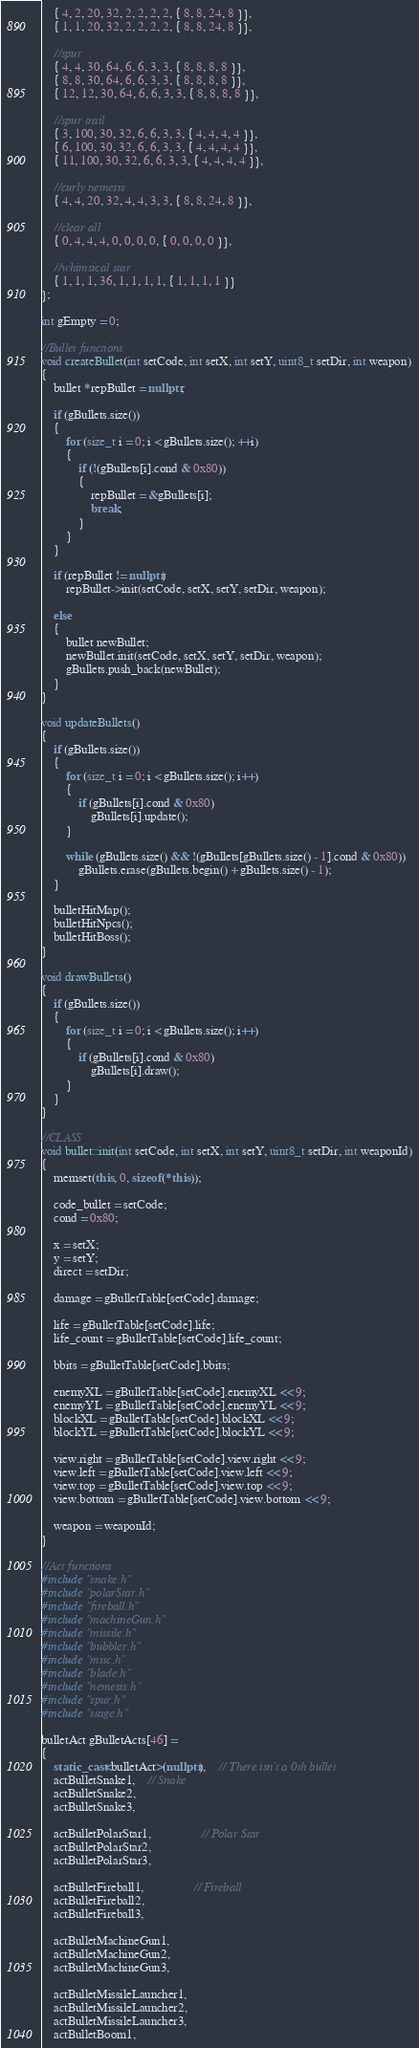Convert code to text. <code><loc_0><loc_0><loc_500><loc_500><_C++_>	{ 4, 2, 20, 32, 2, 2, 2, 2, { 8, 8, 24, 8 }},
	{ 1, 1, 20, 32, 2, 2, 2, 2, { 8, 8, 24, 8 }},

	//spur
	{ 4, 4, 30, 64, 6, 6, 3, 3, { 8, 8, 8, 8 }},
	{ 8, 8, 30, 64, 6, 6, 3, 3, { 8, 8, 8, 8 }},
	{ 12, 12, 30, 64, 6, 6, 3, 3, { 8, 8, 8, 8 }},

	//spur trail
	{ 3, 100, 30, 32, 6, 6, 3, 3, { 4, 4, 4, 4 }},
	{ 6, 100, 30, 32, 6, 6, 3, 3, { 4, 4, 4, 4 }},
	{ 11, 100, 30, 32, 6, 6, 3, 3, { 4, 4, 4, 4 }},

	//curly nemesis
	{ 4, 4, 20, 32, 4, 4, 3, 3, { 8, 8, 24, 8 }},

	//clear all
	{ 0, 4, 4, 4, 0, 0, 0, 0, { 0, 0, 0, 0 }},

	//whimsical star
	{ 1, 1, 1, 36, 1, 1, 1, 1, { 1, 1, 1, 1 }}
};

int gEmpty = 0;

//Bullet functions
void createBullet(int setCode, int setX, int setY, uint8_t setDir, int weapon)
{
	bullet *repBullet = nullptr;

	if (gBullets.size())
	{
		for (size_t i = 0; i < gBullets.size(); ++i)
		{
			if (!(gBullets[i].cond & 0x80))
			{
				repBullet = &gBullets[i];
				break;
			}
		}
	}

	if (repBullet != nullptr)
		repBullet->init(setCode, setX, setY, setDir, weapon);

	else
	{
		bullet newBullet;
		newBullet.init(setCode, setX, setY, setDir, weapon);
		gBullets.push_back(newBullet);
	}
}

void updateBullets()
{
	if (gBullets.size())
	{
		for (size_t i = 0; i < gBullets.size(); i++)
		{
			if (gBullets[i].cond & 0x80)
				gBullets[i].update();
		}

		while (gBullets.size() && !(gBullets[gBullets.size() - 1].cond & 0x80))
			gBullets.erase(gBullets.begin() + gBullets.size() - 1);
	}

	bulletHitMap();
	bulletHitNpcs();
	bulletHitBoss();
}

void drawBullets()
{
	if (gBullets.size())
	{
		for (size_t i = 0; i < gBullets.size(); i++)
		{
			if (gBullets[i].cond & 0x80)
				gBullets[i].draw();
		}
	}
}

//CLASS
void bullet::init(int setCode, int setX, int setY, uint8_t setDir, int weaponId)
{
	memset(this, 0, sizeof(*this));

	code_bullet = setCode;
	cond = 0x80;

	x = setX;
	y = setY;
	direct = setDir;

	damage = gBulletTable[setCode].damage;

	life = gBulletTable[setCode].life;
	life_count = gBulletTable[setCode].life_count;

	bbits = gBulletTable[setCode].bbits;

	enemyXL = gBulletTable[setCode].enemyXL << 9;
	enemyYL = gBulletTable[setCode].enemyYL << 9;
	blockXL = gBulletTable[setCode].blockXL << 9;
	blockYL = gBulletTable[setCode].blockYL << 9;

	view.right = gBulletTable[setCode].view.right << 9;
	view.left = gBulletTable[setCode].view.left << 9;
	view.top = gBulletTable[setCode].view.top << 9;
	view.bottom = gBulletTable[setCode].view.bottom << 9;

	weapon = weaponId;
}

//Act functions
#include "snake.h"
#include "polarStar.h"
#include "fireball.h"
#include "machineGun.h"
#include "missile.h"
#include "bubbler.h"
#include "misc.h"
#include "blade.h"
#include "nemesis.h"
#include "spur.h"
#include "stage.h"

bulletAct gBulletActs[46] =
{
	static_cast<bulletAct>(nullptr),	// There isn't a 0th bullet
	actBulletSnake1,	// Snake
	actBulletSnake2,
	actBulletSnake3,

	actBulletPolarStar1,				// Polar Star
	actBulletPolarStar2,
	actBulletPolarStar3,

	actBulletFireball1,				// Fireball
	actBulletFireball2,
	actBulletFireball3,

	actBulletMachineGun1,
	actBulletMachineGun2,
	actBulletMachineGun3,

	actBulletMissileLauncher1,
	actBulletMissileLauncher2,
	actBulletMissileLauncher3,
	actBulletBoom1,</code> 